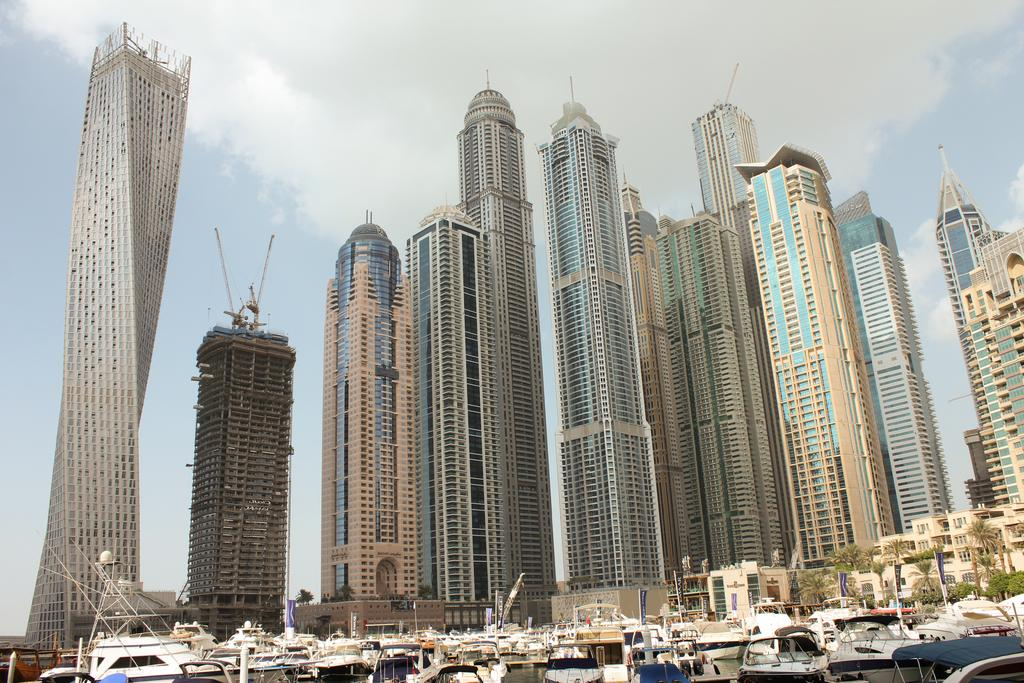What type of vehicles can be seen in the image? There are no vehicles present in the image; it features boats. What type of vegetation is visible in the image? There are trees in the image. What type of structures can be seen in the image? There are buildings in the image. What is visible in the background of the image? The sky is visible in the background of the image. What can be seen in the sky in the image? Clouds are present in the sky. What type of butter is being used to grease the man's hands in the image? There is no man or butter present in the image; it features boats, trees, buildings, and a sky with clouds. 